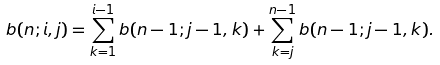Convert formula to latex. <formula><loc_0><loc_0><loc_500><loc_500>b ( n ; i , j ) = \sum _ { k = 1 } ^ { i - 1 } b ( n - 1 ; j - 1 , k ) + \sum _ { k = j } ^ { n - 1 } b ( n - 1 ; j - 1 , k ) .</formula> 